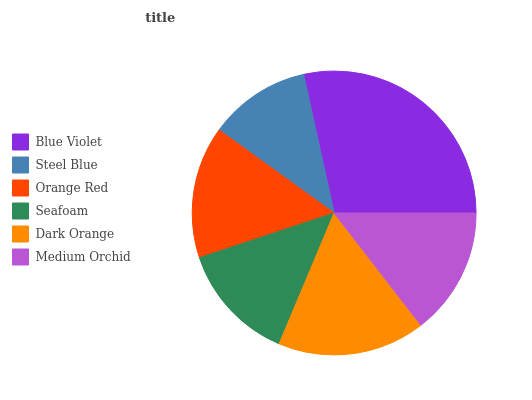Is Steel Blue the minimum?
Answer yes or no. Yes. Is Blue Violet the maximum?
Answer yes or no. Yes. Is Orange Red the minimum?
Answer yes or no. No. Is Orange Red the maximum?
Answer yes or no. No. Is Orange Red greater than Steel Blue?
Answer yes or no. Yes. Is Steel Blue less than Orange Red?
Answer yes or no. Yes. Is Steel Blue greater than Orange Red?
Answer yes or no. No. Is Orange Red less than Steel Blue?
Answer yes or no. No. Is Orange Red the high median?
Answer yes or no. Yes. Is Medium Orchid the low median?
Answer yes or no. Yes. Is Dark Orange the high median?
Answer yes or no. No. Is Orange Red the low median?
Answer yes or no. No. 